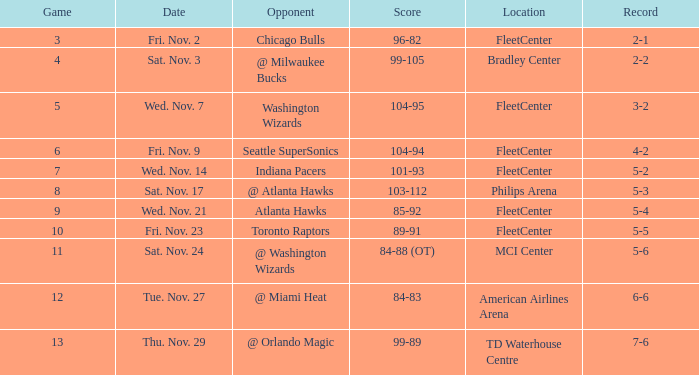When did a game at fleetcenter occur with a 104-94 score and a figure lower than 9? Fri. Nov. 9. 